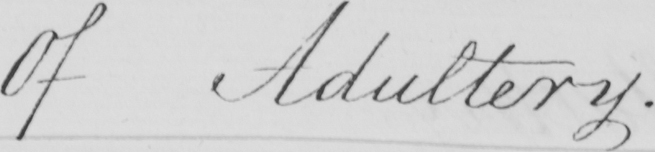What is written in this line of handwriting? Of Adultery . 